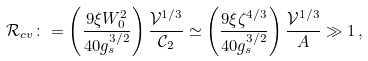Convert formula to latex. <formula><loc_0><loc_0><loc_500><loc_500>\mathcal { R } _ { c v } \colon = \left ( \frac { 9 \xi W _ { 0 } ^ { 2 } } { 4 0 g _ { s } ^ { 3 / 2 } } \right ) \frac { \mathcal { V } ^ { 1 / 3 } } { \mathcal { C } _ { 2 } } \simeq \left ( \frac { 9 \xi \zeta ^ { 4 / 3 } } { 4 0 g _ { s } ^ { 3 / 2 } } \right ) \frac { \mathcal { V } ^ { 1 / 3 } } { A } \gg 1 \, ,</formula> 